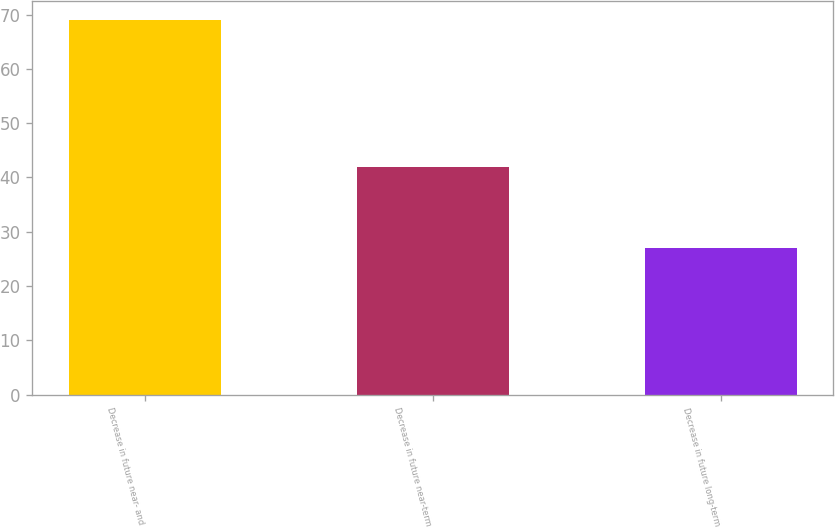<chart> <loc_0><loc_0><loc_500><loc_500><bar_chart><fcel>Decrease in future near- and<fcel>Decrease in future near-term<fcel>Decrease in future long-term<nl><fcel>69<fcel>42<fcel>27<nl></chart> 